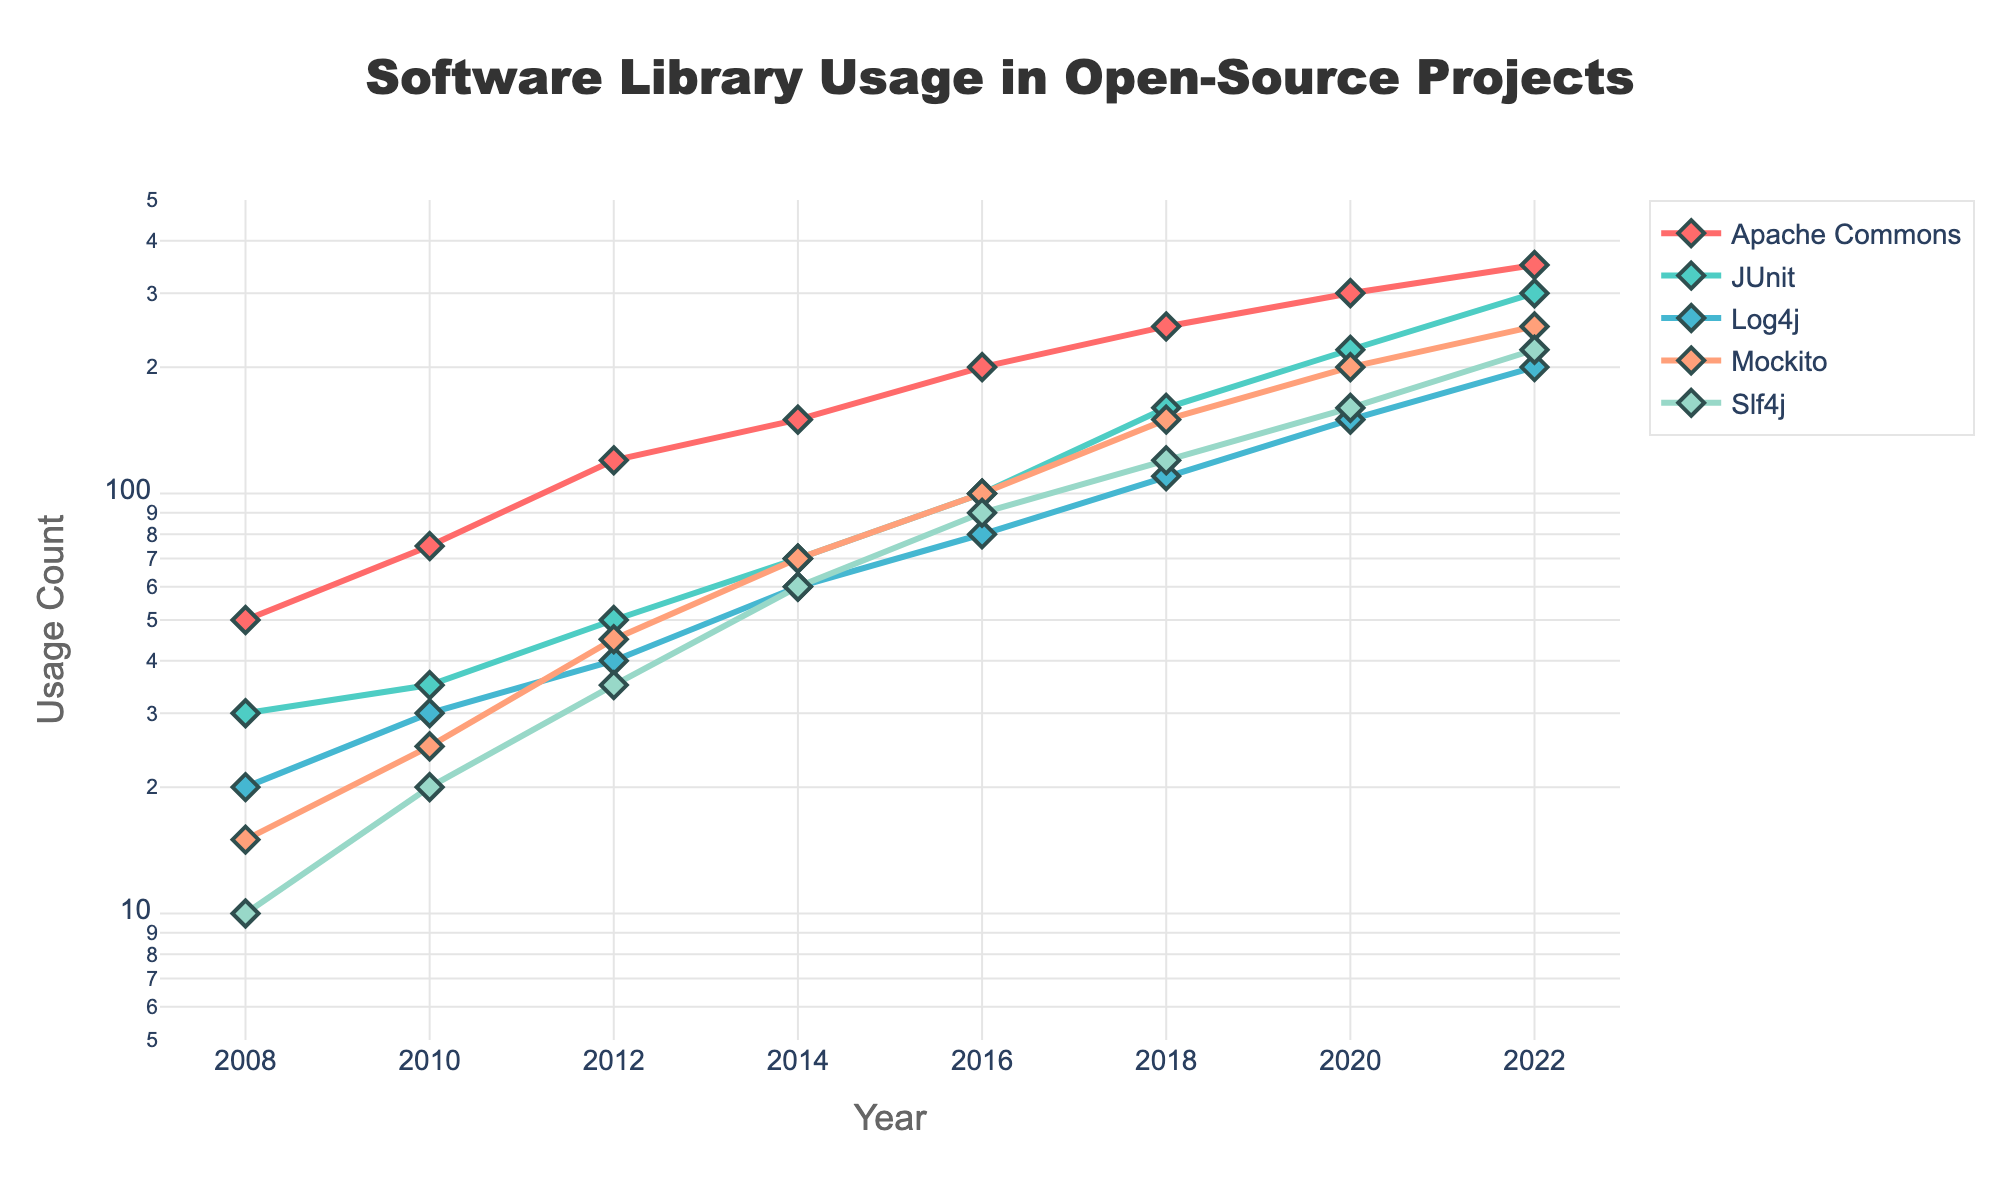What is the title of the plot? The title of the plot is placed at the top center and is often in a larger, bold font. Reading the title from the plot, it says "Software Library Usage in Open-Source Projects".
Answer: Software Library Usage in Open-Source Projects Which library has the highest usage count in 2022? Locate the year 2022 on the x-axis, then check the corresponding usage counts on the y-axis for each library. Apache Commons shows the highest value at 350.
Answer: Apache Commons What is the range of the y-axis in the plot? The y-axis represents the usage count and is set on a logarithmic scale. The range is from the log value of 5 to the log value of 500.
Answer: 5 to 500 How does the usage count of Mockito change from 2008 to 2022? Identify the data points for Mockito at 2008 and 2022. In 2008, it's at 15, and in 2022, it's at 250. The usage count increased significantly.
Answer: Increased from 15 to 250 Which library shows the least growth over the years 2008 to 2022? Compare the start and end values for each library. The smallest growth is seen with Log4j, growing from 20 in 2008 to 200 in 2022. Although growth is considerable, relatively, it's the smallest.
Answer: Log4j Describe the trend of Slf4j from 2008 to 2022. Slf4j starts at 10 in 2008 and increases gradually over the years reaching 220 by 2022. The trend shows steady and consistent growth.
Answer: Steady growth from 10 to 220 What is the sum of usage counts for Apache Commons and JUnit in 2018? Find the values for Apache Commons and JUnit in 2018; they are 250 and 160, respectively. Adding them together gives 410.
Answer: 410 How does the usage count of JUnit in 2016 compare with that of Log4j in the same year? Locate 2016 on the x-axis, and compare usage counts on the y-axis. JUnit is at 100, and Log4j is at 80. JUnit's count is higher.
Answer: JUnit's count is higher Which year shows the largest single-year increase in usage count for Mockito? Analyze the year-by-year increase for Mockito. Notable jumps occur between various years, including 2014-2016 (from 70 to 100) and 2016-2018 (from 100 to 150). Calculate increases, and the largest increase is from 2016 to 2018 with a 50 increase.
Answer: 2016 to 2018 What can be inferred about the growth rate of libraries on a logarithmic scale? On a log scale, consistent spacing indicates exponential growth. Libraries show consistent upward trends indicating steady exponential growth over time.
Answer: Steady exponential growth 